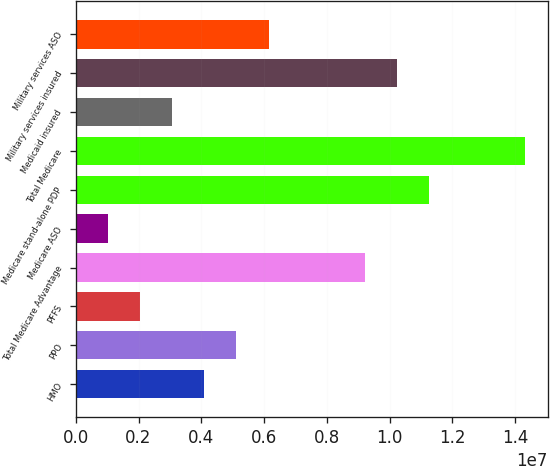Convert chart. <chart><loc_0><loc_0><loc_500><loc_500><bar_chart><fcel>HMO<fcel>PPO<fcel>PFFS<fcel>Total Medicare Advantage<fcel>Medicare ASO<fcel>Medicare stand-alone PDP<fcel>Total Medicare<fcel>Medicaid insured<fcel>Military services insured<fcel>Military services ASO<nl><fcel>4.0952e+06<fcel>5.119e+06<fcel>2.0476e+06<fcel>9.2142e+06<fcel>1.0238e+06<fcel>1.12618e+07<fcel>1.43332e+07<fcel>3.0714e+06<fcel>1.0238e+07<fcel>6.1428e+06<nl></chart> 